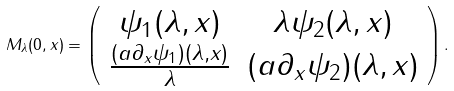Convert formula to latex. <formula><loc_0><loc_0><loc_500><loc_500>M _ { \lambda } ( 0 , x ) = \left ( \begin{array} { c c } \psi _ { 1 } ( \lambda , x ) & \lambda \psi _ { 2 } ( \lambda , x ) \\ \frac { ( a \partial _ { x } \psi _ { 1 } ) ( \lambda , x ) } { \lambda } & ( a \partial _ { x } \psi _ { 2 } ) ( \lambda , x ) \\ \end{array} \right ) .</formula> 